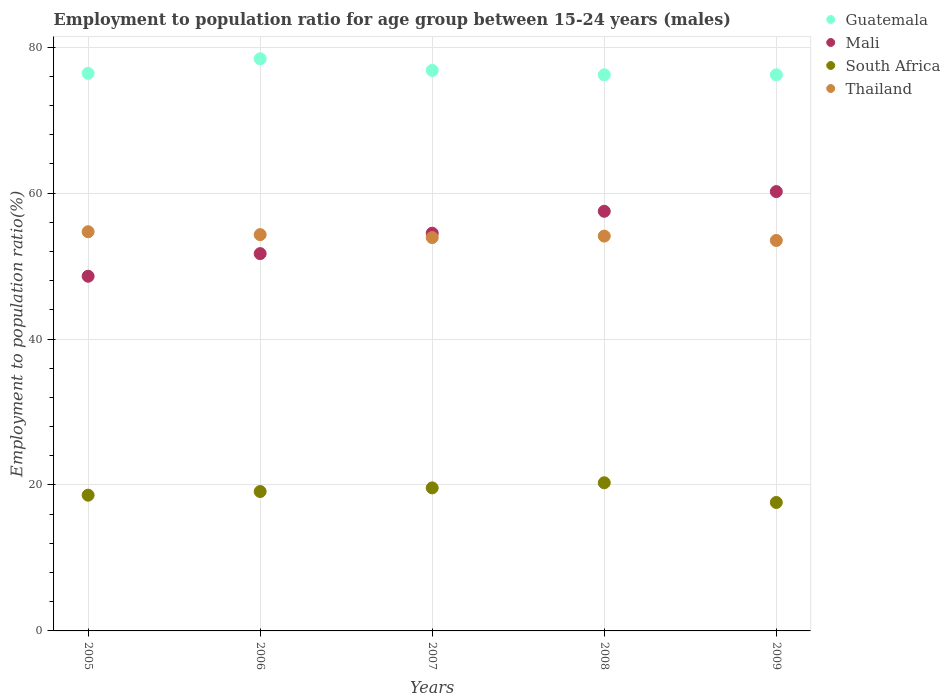How many different coloured dotlines are there?
Your response must be concise. 4. What is the employment to population ratio in South Africa in 2009?
Ensure brevity in your answer.  17.6. Across all years, what is the maximum employment to population ratio in Thailand?
Keep it short and to the point. 54.7. Across all years, what is the minimum employment to population ratio in Thailand?
Offer a very short reply. 53.5. What is the total employment to population ratio in Guatemala in the graph?
Give a very brief answer. 384. What is the difference between the employment to population ratio in Mali in 2005 and that in 2008?
Your answer should be very brief. -8.9. What is the difference between the employment to population ratio in South Africa in 2005 and the employment to population ratio in Mali in 2007?
Keep it short and to the point. -35.9. What is the average employment to population ratio in Thailand per year?
Offer a terse response. 54.1. In the year 2005, what is the difference between the employment to population ratio in Guatemala and employment to population ratio in Mali?
Provide a succinct answer. 27.8. In how many years, is the employment to population ratio in South Africa greater than 40 %?
Provide a short and direct response. 0. What is the ratio of the employment to population ratio in South Africa in 2005 to that in 2007?
Offer a very short reply. 0.95. Is the employment to population ratio in Mali in 2005 less than that in 2008?
Your answer should be very brief. Yes. Is the difference between the employment to population ratio in Guatemala in 2005 and 2006 greater than the difference between the employment to population ratio in Mali in 2005 and 2006?
Provide a succinct answer. Yes. What is the difference between the highest and the second highest employment to population ratio in Mali?
Your response must be concise. 2.7. What is the difference between the highest and the lowest employment to population ratio in South Africa?
Your answer should be very brief. 2.7. In how many years, is the employment to population ratio in Mali greater than the average employment to population ratio in Mali taken over all years?
Provide a short and direct response. 2. Is the employment to population ratio in Guatemala strictly greater than the employment to population ratio in Thailand over the years?
Make the answer very short. Yes. How many dotlines are there?
Offer a very short reply. 4. How many years are there in the graph?
Your response must be concise. 5. What is the difference between two consecutive major ticks on the Y-axis?
Provide a short and direct response. 20. Are the values on the major ticks of Y-axis written in scientific E-notation?
Your answer should be very brief. No. Does the graph contain grids?
Provide a short and direct response. Yes. How many legend labels are there?
Your answer should be compact. 4. How are the legend labels stacked?
Provide a short and direct response. Vertical. What is the title of the graph?
Give a very brief answer. Employment to population ratio for age group between 15-24 years (males). What is the Employment to population ratio(%) of Guatemala in 2005?
Keep it short and to the point. 76.4. What is the Employment to population ratio(%) in Mali in 2005?
Make the answer very short. 48.6. What is the Employment to population ratio(%) in South Africa in 2005?
Your answer should be compact. 18.6. What is the Employment to population ratio(%) in Thailand in 2005?
Your response must be concise. 54.7. What is the Employment to population ratio(%) of Guatemala in 2006?
Offer a terse response. 78.4. What is the Employment to population ratio(%) in Mali in 2006?
Provide a short and direct response. 51.7. What is the Employment to population ratio(%) of South Africa in 2006?
Provide a succinct answer. 19.1. What is the Employment to population ratio(%) in Thailand in 2006?
Your answer should be compact. 54.3. What is the Employment to population ratio(%) of Guatemala in 2007?
Ensure brevity in your answer.  76.8. What is the Employment to population ratio(%) of Mali in 2007?
Provide a succinct answer. 54.5. What is the Employment to population ratio(%) of South Africa in 2007?
Offer a very short reply. 19.6. What is the Employment to population ratio(%) in Thailand in 2007?
Offer a terse response. 53.9. What is the Employment to population ratio(%) of Guatemala in 2008?
Keep it short and to the point. 76.2. What is the Employment to population ratio(%) of Mali in 2008?
Keep it short and to the point. 57.5. What is the Employment to population ratio(%) in South Africa in 2008?
Your answer should be very brief. 20.3. What is the Employment to population ratio(%) of Thailand in 2008?
Your answer should be very brief. 54.1. What is the Employment to population ratio(%) in Guatemala in 2009?
Your response must be concise. 76.2. What is the Employment to population ratio(%) in Mali in 2009?
Your answer should be very brief. 60.2. What is the Employment to population ratio(%) of South Africa in 2009?
Keep it short and to the point. 17.6. What is the Employment to population ratio(%) in Thailand in 2009?
Keep it short and to the point. 53.5. Across all years, what is the maximum Employment to population ratio(%) in Guatemala?
Provide a succinct answer. 78.4. Across all years, what is the maximum Employment to population ratio(%) of Mali?
Provide a short and direct response. 60.2. Across all years, what is the maximum Employment to population ratio(%) in South Africa?
Ensure brevity in your answer.  20.3. Across all years, what is the maximum Employment to population ratio(%) in Thailand?
Offer a terse response. 54.7. Across all years, what is the minimum Employment to population ratio(%) in Guatemala?
Ensure brevity in your answer.  76.2. Across all years, what is the minimum Employment to population ratio(%) in Mali?
Your response must be concise. 48.6. Across all years, what is the minimum Employment to population ratio(%) in South Africa?
Give a very brief answer. 17.6. Across all years, what is the minimum Employment to population ratio(%) in Thailand?
Keep it short and to the point. 53.5. What is the total Employment to population ratio(%) in Guatemala in the graph?
Provide a succinct answer. 384. What is the total Employment to population ratio(%) of Mali in the graph?
Provide a short and direct response. 272.5. What is the total Employment to population ratio(%) in South Africa in the graph?
Your answer should be very brief. 95.2. What is the total Employment to population ratio(%) of Thailand in the graph?
Your answer should be very brief. 270.5. What is the difference between the Employment to population ratio(%) of South Africa in 2005 and that in 2006?
Give a very brief answer. -0.5. What is the difference between the Employment to population ratio(%) of Guatemala in 2005 and that in 2007?
Give a very brief answer. -0.4. What is the difference between the Employment to population ratio(%) of South Africa in 2005 and that in 2007?
Your answer should be very brief. -1. What is the difference between the Employment to population ratio(%) in Thailand in 2005 and that in 2007?
Provide a succinct answer. 0.8. What is the difference between the Employment to population ratio(%) in Mali in 2005 and that in 2008?
Provide a short and direct response. -8.9. What is the difference between the Employment to population ratio(%) of Thailand in 2005 and that in 2008?
Your answer should be compact. 0.6. What is the difference between the Employment to population ratio(%) in Mali in 2005 and that in 2009?
Your answer should be compact. -11.6. What is the difference between the Employment to population ratio(%) in South Africa in 2005 and that in 2009?
Make the answer very short. 1. What is the difference between the Employment to population ratio(%) in South Africa in 2006 and that in 2007?
Provide a short and direct response. -0.5. What is the difference between the Employment to population ratio(%) in Thailand in 2006 and that in 2007?
Your response must be concise. 0.4. What is the difference between the Employment to population ratio(%) in Guatemala in 2006 and that in 2008?
Provide a succinct answer. 2.2. What is the difference between the Employment to population ratio(%) in South Africa in 2006 and that in 2008?
Your response must be concise. -1.2. What is the difference between the Employment to population ratio(%) in Guatemala in 2006 and that in 2009?
Keep it short and to the point. 2.2. What is the difference between the Employment to population ratio(%) in Thailand in 2007 and that in 2008?
Offer a terse response. -0.2. What is the difference between the Employment to population ratio(%) in South Africa in 2007 and that in 2009?
Ensure brevity in your answer.  2. What is the difference between the Employment to population ratio(%) of Thailand in 2007 and that in 2009?
Your answer should be very brief. 0.4. What is the difference between the Employment to population ratio(%) of Guatemala in 2008 and that in 2009?
Your answer should be very brief. 0. What is the difference between the Employment to population ratio(%) in Mali in 2008 and that in 2009?
Make the answer very short. -2.7. What is the difference between the Employment to population ratio(%) of South Africa in 2008 and that in 2009?
Provide a succinct answer. 2.7. What is the difference between the Employment to population ratio(%) of Thailand in 2008 and that in 2009?
Provide a succinct answer. 0.6. What is the difference between the Employment to population ratio(%) of Guatemala in 2005 and the Employment to population ratio(%) of Mali in 2006?
Give a very brief answer. 24.7. What is the difference between the Employment to population ratio(%) in Guatemala in 2005 and the Employment to population ratio(%) in South Africa in 2006?
Your answer should be compact. 57.3. What is the difference between the Employment to population ratio(%) of Guatemala in 2005 and the Employment to population ratio(%) of Thailand in 2006?
Make the answer very short. 22.1. What is the difference between the Employment to population ratio(%) of Mali in 2005 and the Employment to population ratio(%) of South Africa in 2006?
Give a very brief answer. 29.5. What is the difference between the Employment to population ratio(%) in Mali in 2005 and the Employment to population ratio(%) in Thailand in 2006?
Ensure brevity in your answer.  -5.7. What is the difference between the Employment to population ratio(%) of South Africa in 2005 and the Employment to population ratio(%) of Thailand in 2006?
Give a very brief answer. -35.7. What is the difference between the Employment to population ratio(%) in Guatemala in 2005 and the Employment to population ratio(%) in Mali in 2007?
Offer a very short reply. 21.9. What is the difference between the Employment to population ratio(%) of Guatemala in 2005 and the Employment to population ratio(%) of South Africa in 2007?
Ensure brevity in your answer.  56.8. What is the difference between the Employment to population ratio(%) in Guatemala in 2005 and the Employment to population ratio(%) in Thailand in 2007?
Make the answer very short. 22.5. What is the difference between the Employment to population ratio(%) of Mali in 2005 and the Employment to population ratio(%) of South Africa in 2007?
Ensure brevity in your answer.  29. What is the difference between the Employment to population ratio(%) of Mali in 2005 and the Employment to population ratio(%) of Thailand in 2007?
Offer a terse response. -5.3. What is the difference between the Employment to population ratio(%) in South Africa in 2005 and the Employment to population ratio(%) in Thailand in 2007?
Offer a very short reply. -35.3. What is the difference between the Employment to population ratio(%) of Guatemala in 2005 and the Employment to population ratio(%) of South Africa in 2008?
Provide a succinct answer. 56.1. What is the difference between the Employment to population ratio(%) in Guatemala in 2005 and the Employment to population ratio(%) in Thailand in 2008?
Keep it short and to the point. 22.3. What is the difference between the Employment to population ratio(%) of Mali in 2005 and the Employment to population ratio(%) of South Africa in 2008?
Keep it short and to the point. 28.3. What is the difference between the Employment to population ratio(%) of South Africa in 2005 and the Employment to population ratio(%) of Thailand in 2008?
Provide a short and direct response. -35.5. What is the difference between the Employment to population ratio(%) of Guatemala in 2005 and the Employment to population ratio(%) of Mali in 2009?
Make the answer very short. 16.2. What is the difference between the Employment to population ratio(%) in Guatemala in 2005 and the Employment to population ratio(%) in South Africa in 2009?
Give a very brief answer. 58.8. What is the difference between the Employment to population ratio(%) in Guatemala in 2005 and the Employment to population ratio(%) in Thailand in 2009?
Provide a succinct answer. 22.9. What is the difference between the Employment to population ratio(%) of Mali in 2005 and the Employment to population ratio(%) of South Africa in 2009?
Provide a succinct answer. 31. What is the difference between the Employment to population ratio(%) in Mali in 2005 and the Employment to population ratio(%) in Thailand in 2009?
Offer a terse response. -4.9. What is the difference between the Employment to population ratio(%) of South Africa in 2005 and the Employment to population ratio(%) of Thailand in 2009?
Offer a very short reply. -34.9. What is the difference between the Employment to population ratio(%) in Guatemala in 2006 and the Employment to population ratio(%) in Mali in 2007?
Your answer should be compact. 23.9. What is the difference between the Employment to population ratio(%) of Guatemala in 2006 and the Employment to population ratio(%) of South Africa in 2007?
Keep it short and to the point. 58.8. What is the difference between the Employment to population ratio(%) in Mali in 2006 and the Employment to population ratio(%) in South Africa in 2007?
Keep it short and to the point. 32.1. What is the difference between the Employment to population ratio(%) of South Africa in 2006 and the Employment to population ratio(%) of Thailand in 2007?
Offer a very short reply. -34.8. What is the difference between the Employment to population ratio(%) in Guatemala in 2006 and the Employment to population ratio(%) in Mali in 2008?
Provide a succinct answer. 20.9. What is the difference between the Employment to population ratio(%) of Guatemala in 2006 and the Employment to population ratio(%) of South Africa in 2008?
Offer a very short reply. 58.1. What is the difference between the Employment to population ratio(%) in Guatemala in 2006 and the Employment to population ratio(%) in Thailand in 2008?
Your answer should be compact. 24.3. What is the difference between the Employment to population ratio(%) in Mali in 2006 and the Employment to population ratio(%) in South Africa in 2008?
Give a very brief answer. 31.4. What is the difference between the Employment to population ratio(%) of Mali in 2006 and the Employment to population ratio(%) of Thailand in 2008?
Give a very brief answer. -2.4. What is the difference between the Employment to population ratio(%) in South Africa in 2006 and the Employment to population ratio(%) in Thailand in 2008?
Your answer should be compact. -35. What is the difference between the Employment to population ratio(%) in Guatemala in 2006 and the Employment to population ratio(%) in Mali in 2009?
Provide a short and direct response. 18.2. What is the difference between the Employment to population ratio(%) in Guatemala in 2006 and the Employment to population ratio(%) in South Africa in 2009?
Your answer should be very brief. 60.8. What is the difference between the Employment to population ratio(%) of Guatemala in 2006 and the Employment to population ratio(%) of Thailand in 2009?
Give a very brief answer. 24.9. What is the difference between the Employment to population ratio(%) of Mali in 2006 and the Employment to population ratio(%) of South Africa in 2009?
Your answer should be compact. 34.1. What is the difference between the Employment to population ratio(%) in South Africa in 2006 and the Employment to population ratio(%) in Thailand in 2009?
Make the answer very short. -34.4. What is the difference between the Employment to population ratio(%) of Guatemala in 2007 and the Employment to population ratio(%) of Mali in 2008?
Provide a short and direct response. 19.3. What is the difference between the Employment to population ratio(%) in Guatemala in 2007 and the Employment to population ratio(%) in South Africa in 2008?
Your answer should be very brief. 56.5. What is the difference between the Employment to population ratio(%) of Guatemala in 2007 and the Employment to population ratio(%) of Thailand in 2008?
Offer a terse response. 22.7. What is the difference between the Employment to population ratio(%) in Mali in 2007 and the Employment to population ratio(%) in South Africa in 2008?
Your answer should be compact. 34.2. What is the difference between the Employment to population ratio(%) in Mali in 2007 and the Employment to population ratio(%) in Thailand in 2008?
Offer a terse response. 0.4. What is the difference between the Employment to population ratio(%) in South Africa in 2007 and the Employment to population ratio(%) in Thailand in 2008?
Offer a very short reply. -34.5. What is the difference between the Employment to population ratio(%) in Guatemala in 2007 and the Employment to population ratio(%) in Mali in 2009?
Your answer should be very brief. 16.6. What is the difference between the Employment to population ratio(%) of Guatemala in 2007 and the Employment to population ratio(%) of South Africa in 2009?
Give a very brief answer. 59.2. What is the difference between the Employment to population ratio(%) of Guatemala in 2007 and the Employment to population ratio(%) of Thailand in 2009?
Offer a terse response. 23.3. What is the difference between the Employment to population ratio(%) of Mali in 2007 and the Employment to population ratio(%) of South Africa in 2009?
Make the answer very short. 36.9. What is the difference between the Employment to population ratio(%) of South Africa in 2007 and the Employment to population ratio(%) of Thailand in 2009?
Give a very brief answer. -33.9. What is the difference between the Employment to population ratio(%) in Guatemala in 2008 and the Employment to population ratio(%) in Mali in 2009?
Offer a very short reply. 16. What is the difference between the Employment to population ratio(%) in Guatemala in 2008 and the Employment to population ratio(%) in South Africa in 2009?
Offer a very short reply. 58.6. What is the difference between the Employment to population ratio(%) in Guatemala in 2008 and the Employment to population ratio(%) in Thailand in 2009?
Keep it short and to the point. 22.7. What is the difference between the Employment to population ratio(%) in Mali in 2008 and the Employment to population ratio(%) in South Africa in 2009?
Keep it short and to the point. 39.9. What is the difference between the Employment to population ratio(%) in South Africa in 2008 and the Employment to population ratio(%) in Thailand in 2009?
Keep it short and to the point. -33.2. What is the average Employment to population ratio(%) in Guatemala per year?
Offer a terse response. 76.8. What is the average Employment to population ratio(%) in Mali per year?
Make the answer very short. 54.5. What is the average Employment to population ratio(%) of South Africa per year?
Offer a very short reply. 19.04. What is the average Employment to population ratio(%) in Thailand per year?
Keep it short and to the point. 54.1. In the year 2005, what is the difference between the Employment to population ratio(%) of Guatemala and Employment to population ratio(%) of Mali?
Make the answer very short. 27.8. In the year 2005, what is the difference between the Employment to population ratio(%) of Guatemala and Employment to population ratio(%) of South Africa?
Your response must be concise. 57.8. In the year 2005, what is the difference between the Employment to population ratio(%) of Guatemala and Employment to population ratio(%) of Thailand?
Your answer should be compact. 21.7. In the year 2005, what is the difference between the Employment to population ratio(%) in South Africa and Employment to population ratio(%) in Thailand?
Keep it short and to the point. -36.1. In the year 2006, what is the difference between the Employment to population ratio(%) in Guatemala and Employment to population ratio(%) in Mali?
Keep it short and to the point. 26.7. In the year 2006, what is the difference between the Employment to population ratio(%) of Guatemala and Employment to population ratio(%) of South Africa?
Provide a succinct answer. 59.3. In the year 2006, what is the difference between the Employment to population ratio(%) in Guatemala and Employment to population ratio(%) in Thailand?
Offer a very short reply. 24.1. In the year 2006, what is the difference between the Employment to population ratio(%) of Mali and Employment to population ratio(%) of South Africa?
Provide a succinct answer. 32.6. In the year 2006, what is the difference between the Employment to population ratio(%) of Mali and Employment to population ratio(%) of Thailand?
Provide a succinct answer. -2.6. In the year 2006, what is the difference between the Employment to population ratio(%) of South Africa and Employment to population ratio(%) of Thailand?
Your response must be concise. -35.2. In the year 2007, what is the difference between the Employment to population ratio(%) in Guatemala and Employment to population ratio(%) in Mali?
Give a very brief answer. 22.3. In the year 2007, what is the difference between the Employment to population ratio(%) of Guatemala and Employment to population ratio(%) of South Africa?
Provide a short and direct response. 57.2. In the year 2007, what is the difference between the Employment to population ratio(%) in Guatemala and Employment to population ratio(%) in Thailand?
Provide a succinct answer. 22.9. In the year 2007, what is the difference between the Employment to population ratio(%) in Mali and Employment to population ratio(%) in South Africa?
Ensure brevity in your answer.  34.9. In the year 2007, what is the difference between the Employment to population ratio(%) in South Africa and Employment to population ratio(%) in Thailand?
Ensure brevity in your answer.  -34.3. In the year 2008, what is the difference between the Employment to population ratio(%) of Guatemala and Employment to population ratio(%) of Mali?
Your answer should be very brief. 18.7. In the year 2008, what is the difference between the Employment to population ratio(%) in Guatemala and Employment to population ratio(%) in South Africa?
Your answer should be compact. 55.9. In the year 2008, what is the difference between the Employment to population ratio(%) in Guatemala and Employment to population ratio(%) in Thailand?
Your answer should be compact. 22.1. In the year 2008, what is the difference between the Employment to population ratio(%) in Mali and Employment to population ratio(%) in South Africa?
Offer a very short reply. 37.2. In the year 2008, what is the difference between the Employment to population ratio(%) in Mali and Employment to population ratio(%) in Thailand?
Offer a very short reply. 3.4. In the year 2008, what is the difference between the Employment to population ratio(%) of South Africa and Employment to population ratio(%) of Thailand?
Offer a very short reply. -33.8. In the year 2009, what is the difference between the Employment to population ratio(%) in Guatemala and Employment to population ratio(%) in South Africa?
Provide a short and direct response. 58.6. In the year 2009, what is the difference between the Employment to population ratio(%) in Guatemala and Employment to population ratio(%) in Thailand?
Offer a very short reply. 22.7. In the year 2009, what is the difference between the Employment to population ratio(%) of Mali and Employment to population ratio(%) of South Africa?
Give a very brief answer. 42.6. In the year 2009, what is the difference between the Employment to population ratio(%) in South Africa and Employment to population ratio(%) in Thailand?
Provide a succinct answer. -35.9. What is the ratio of the Employment to population ratio(%) in Guatemala in 2005 to that in 2006?
Your answer should be compact. 0.97. What is the ratio of the Employment to population ratio(%) of Mali in 2005 to that in 2006?
Give a very brief answer. 0.94. What is the ratio of the Employment to population ratio(%) in South Africa in 2005 to that in 2006?
Provide a short and direct response. 0.97. What is the ratio of the Employment to population ratio(%) in Thailand in 2005 to that in 2006?
Keep it short and to the point. 1.01. What is the ratio of the Employment to population ratio(%) of Mali in 2005 to that in 2007?
Offer a very short reply. 0.89. What is the ratio of the Employment to population ratio(%) of South Africa in 2005 to that in 2007?
Make the answer very short. 0.95. What is the ratio of the Employment to population ratio(%) in Thailand in 2005 to that in 2007?
Your answer should be very brief. 1.01. What is the ratio of the Employment to population ratio(%) in Mali in 2005 to that in 2008?
Make the answer very short. 0.85. What is the ratio of the Employment to population ratio(%) of South Africa in 2005 to that in 2008?
Give a very brief answer. 0.92. What is the ratio of the Employment to population ratio(%) in Thailand in 2005 to that in 2008?
Your answer should be compact. 1.01. What is the ratio of the Employment to population ratio(%) of Mali in 2005 to that in 2009?
Ensure brevity in your answer.  0.81. What is the ratio of the Employment to population ratio(%) in South Africa in 2005 to that in 2009?
Ensure brevity in your answer.  1.06. What is the ratio of the Employment to population ratio(%) in Thailand in 2005 to that in 2009?
Provide a succinct answer. 1.02. What is the ratio of the Employment to population ratio(%) of Guatemala in 2006 to that in 2007?
Offer a very short reply. 1.02. What is the ratio of the Employment to population ratio(%) of Mali in 2006 to that in 2007?
Make the answer very short. 0.95. What is the ratio of the Employment to population ratio(%) in South Africa in 2006 to that in 2007?
Your response must be concise. 0.97. What is the ratio of the Employment to population ratio(%) of Thailand in 2006 to that in 2007?
Ensure brevity in your answer.  1.01. What is the ratio of the Employment to population ratio(%) of Guatemala in 2006 to that in 2008?
Make the answer very short. 1.03. What is the ratio of the Employment to population ratio(%) of Mali in 2006 to that in 2008?
Your answer should be compact. 0.9. What is the ratio of the Employment to population ratio(%) of South Africa in 2006 to that in 2008?
Your response must be concise. 0.94. What is the ratio of the Employment to population ratio(%) in Thailand in 2006 to that in 2008?
Make the answer very short. 1. What is the ratio of the Employment to population ratio(%) in Guatemala in 2006 to that in 2009?
Give a very brief answer. 1.03. What is the ratio of the Employment to population ratio(%) in Mali in 2006 to that in 2009?
Offer a terse response. 0.86. What is the ratio of the Employment to population ratio(%) of South Africa in 2006 to that in 2009?
Make the answer very short. 1.09. What is the ratio of the Employment to population ratio(%) in Guatemala in 2007 to that in 2008?
Provide a succinct answer. 1.01. What is the ratio of the Employment to population ratio(%) of Mali in 2007 to that in 2008?
Your answer should be compact. 0.95. What is the ratio of the Employment to population ratio(%) of South Africa in 2007 to that in 2008?
Make the answer very short. 0.97. What is the ratio of the Employment to population ratio(%) in Thailand in 2007 to that in 2008?
Your answer should be very brief. 1. What is the ratio of the Employment to population ratio(%) of Guatemala in 2007 to that in 2009?
Your response must be concise. 1.01. What is the ratio of the Employment to population ratio(%) in Mali in 2007 to that in 2009?
Your answer should be compact. 0.91. What is the ratio of the Employment to population ratio(%) in South Africa in 2007 to that in 2009?
Your response must be concise. 1.11. What is the ratio of the Employment to population ratio(%) of Thailand in 2007 to that in 2009?
Your response must be concise. 1.01. What is the ratio of the Employment to population ratio(%) in Guatemala in 2008 to that in 2009?
Make the answer very short. 1. What is the ratio of the Employment to population ratio(%) in Mali in 2008 to that in 2009?
Keep it short and to the point. 0.96. What is the ratio of the Employment to population ratio(%) in South Africa in 2008 to that in 2009?
Your answer should be compact. 1.15. What is the ratio of the Employment to population ratio(%) of Thailand in 2008 to that in 2009?
Offer a terse response. 1.01. What is the difference between the highest and the second highest Employment to population ratio(%) of Mali?
Your response must be concise. 2.7. What is the difference between the highest and the second highest Employment to population ratio(%) of South Africa?
Your answer should be very brief. 0.7. What is the difference between the highest and the second highest Employment to population ratio(%) of Thailand?
Make the answer very short. 0.4. What is the difference between the highest and the lowest Employment to population ratio(%) in Guatemala?
Offer a terse response. 2.2. 